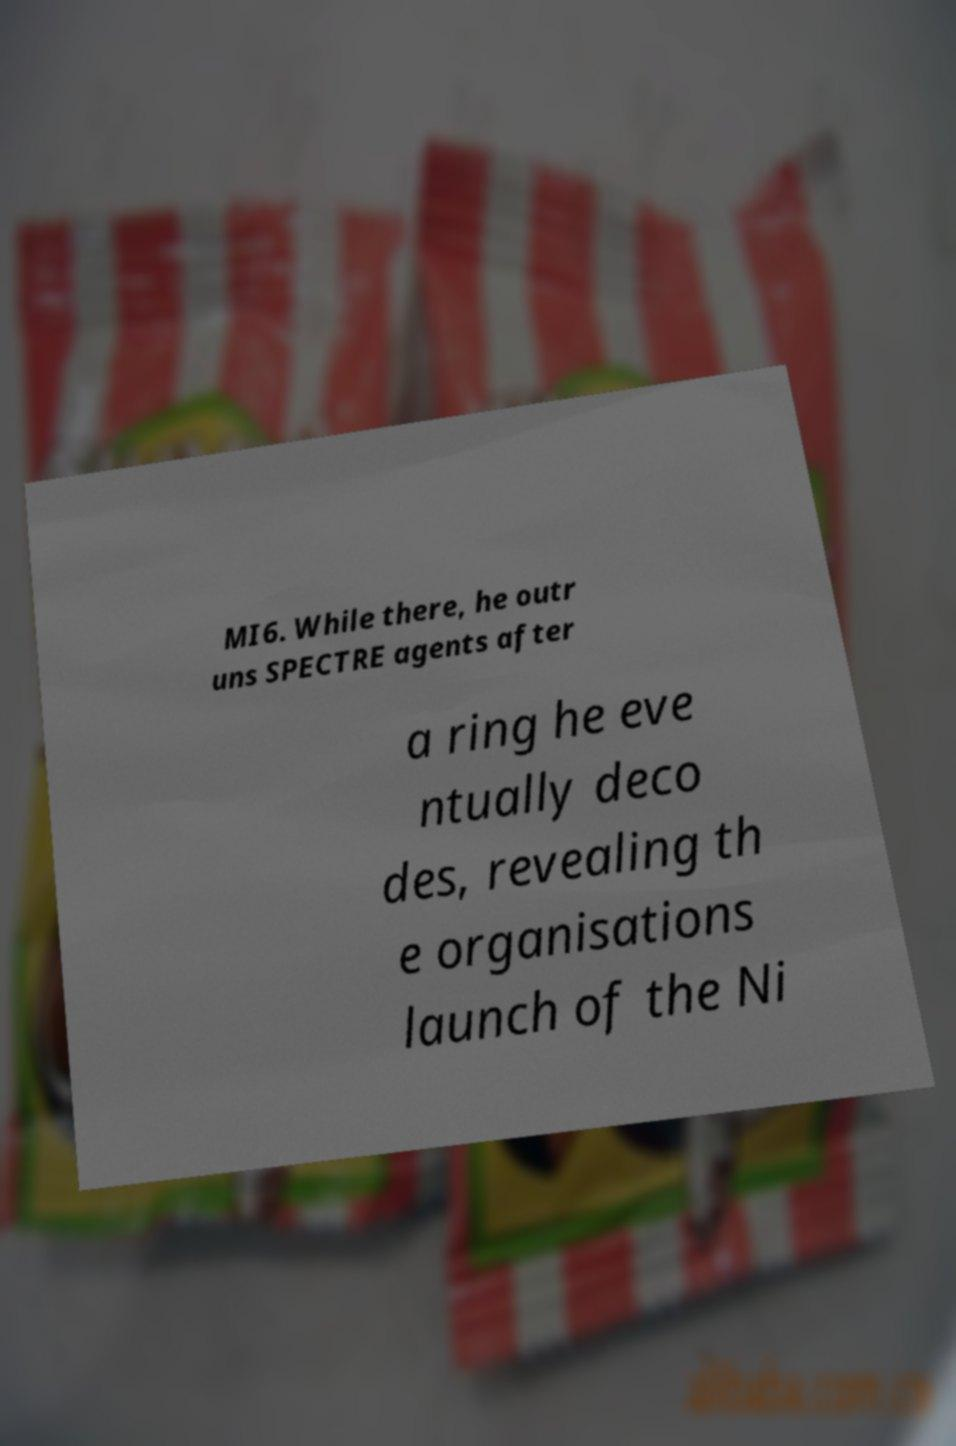I need the written content from this picture converted into text. Can you do that? MI6. While there, he outr uns SPECTRE agents after a ring he eve ntually deco des, revealing th e organisations launch of the Ni 